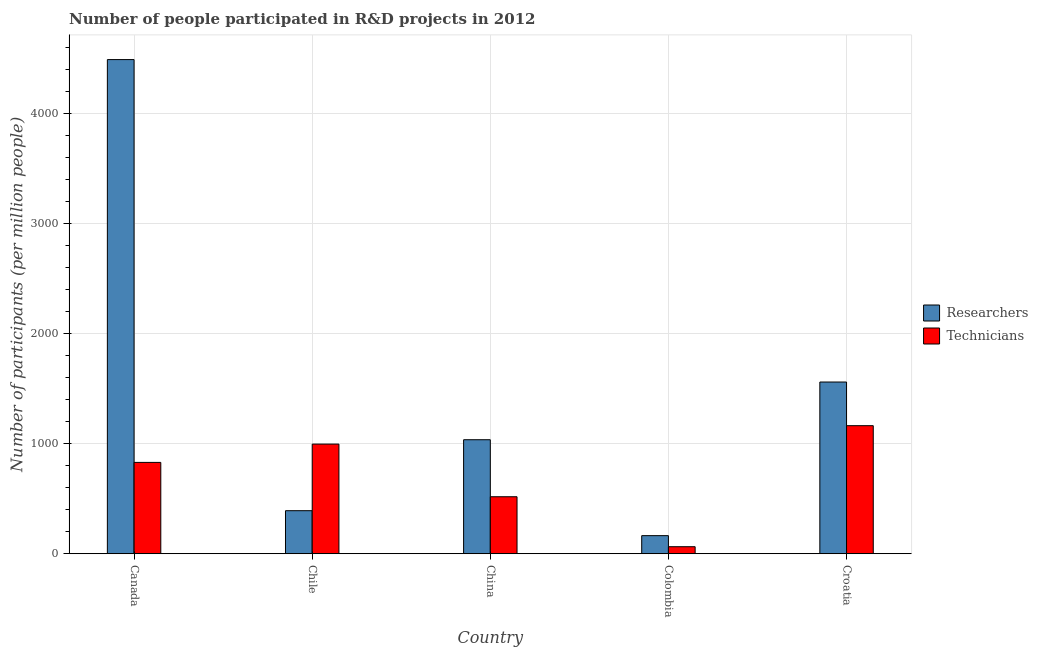How many different coloured bars are there?
Your answer should be compact. 2. How many groups of bars are there?
Provide a short and direct response. 5. Are the number of bars on each tick of the X-axis equal?
Keep it short and to the point. Yes. How many bars are there on the 2nd tick from the right?
Offer a very short reply. 2. What is the label of the 5th group of bars from the left?
Your answer should be compact. Croatia. In how many cases, is the number of bars for a given country not equal to the number of legend labels?
Your answer should be very brief. 0. What is the number of researchers in Croatia?
Ensure brevity in your answer.  1560.06. Across all countries, what is the maximum number of technicians?
Provide a succinct answer. 1163.4. Across all countries, what is the minimum number of technicians?
Your response must be concise. 63.85. In which country was the number of technicians maximum?
Your response must be concise. Croatia. In which country was the number of technicians minimum?
Make the answer very short. Colombia. What is the total number of technicians in the graph?
Make the answer very short. 3571.1. What is the difference between the number of researchers in Chile and that in Colombia?
Your response must be concise. 226.66. What is the difference between the number of technicians in Canada and the number of researchers in Colombia?
Ensure brevity in your answer.  665.6. What is the average number of researchers per country?
Your answer should be compact. 1528.19. What is the difference between the number of technicians and number of researchers in Croatia?
Provide a short and direct response. -396.66. In how many countries, is the number of researchers greater than 1200 ?
Your answer should be compact. 2. What is the ratio of the number of technicians in Chile to that in Colombia?
Provide a succinct answer. 15.6. What is the difference between the highest and the second highest number of technicians?
Keep it short and to the point. 167.19. What is the difference between the highest and the lowest number of technicians?
Ensure brevity in your answer.  1099.55. In how many countries, is the number of researchers greater than the average number of researchers taken over all countries?
Ensure brevity in your answer.  2. Is the sum of the number of researchers in Colombia and Croatia greater than the maximum number of technicians across all countries?
Make the answer very short. Yes. What does the 2nd bar from the left in China represents?
Ensure brevity in your answer.  Technicians. What does the 1st bar from the right in Canada represents?
Offer a terse response. Technicians. How many bars are there?
Your response must be concise. 10. Are all the bars in the graph horizontal?
Provide a succinct answer. No. How many countries are there in the graph?
Your answer should be very brief. 5. Does the graph contain grids?
Provide a succinct answer. Yes. What is the title of the graph?
Give a very brief answer. Number of people participated in R&D projects in 2012. Does "Register a property" appear as one of the legend labels in the graph?
Keep it short and to the point. No. What is the label or title of the Y-axis?
Give a very brief answer. Number of participants (per million people). What is the Number of participants (per million people) in Researchers in Canada?
Your response must be concise. 4489.77. What is the Number of participants (per million people) of Technicians in Canada?
Offer a very short reply. 829.89. What is the Number of participants (per million people) of Researchers in Chile?
Your answer should be compact. 390.95. What is the Number of participants (per million people) of Technicians in Chile?
Your answer should be very brief. 996.21. What is the Number of participants (per million people) in Researchers in China?
Provide a succinct answer. 1035.88. What is the Number of participants (per million people) of Technicians in China?
Your answer should be compact. 517.76. What is the Number of participants (per million people) of Researchers in Colombia?
Make the answer very short. 164.29. What is the Number of participants (per million people) in Technicians in Colombia?
Offer a terse response. 63.85. What is the Number of participants (per million people) of Researchers in Croatia?
Your answer should be compact. 1560.06. What is the Number of participants (per million people) in Technicians in Croatia?
Your answer should be compact. 1163.4. Across all countries, what is the maximum Number of participants (per million people) in Researchers?
Keep it short and to the point. 4489.77. Across all countries, what is the maximum Number of participants (per million people) in Technicians?
Ensure brevity in your answer.  1163.4. Across all countries, what is the minimum Number of participants (per million people) of Researchers?
Your answer should be compact. 164.29. Across all countries, what is the minimum Number of participants (per million people) of Technicians?
Give a very brief answer. 63.85. What is the total Number of participants (per million people) in Researchers in the graph?
Ensure brevity in your answer.  7640.95. What is the total Number of participants (per million people) of Technicians in the graph?
Offer a terse response. 3571.1. What is the difference between the Number of participants (per million people) in Researchers in Canada and that in Chile?
Your answer should be compact. 4098.82. What is the difference between the Number of participants (per million people) in Technicians in Canada and that in Chile?
Make the answer very short. -166.32. What is the difference between the Number of participants (per million people) in Researchers in Canada and that in China?
Your answer should be compact. 3453.89. What is the difference between the Number of participants (per million people) in Technicians in Canada and that in China?
Offer a terse response. 312.13. What is the difference between the Number of participants (per million people) in Researchers in Canada and that in Colombia?
Your answer should be very brief. 4325.48. What is the difference between the Number of participants (per million people) of Technicians in Canada and that in Colombia?
Your answer should be very brief. 766.04. What is the difference between the Number of participants (per million people) in Researchers in Canada and that in Croatia?
Keep it short and to the point. 2929.71. What is the difference between the Number of participants (per million people) in Technicians in Canada and that in Croatia?
Offer a very short reply. -333.51. What is the difference between the Number of participants (per million people) in Researchers in Chile and that in China?
Provide a succinct answer. -644.93. What is the difference between the Number of participants (per million people) of Technicians in Chile and that in China?
Make the answer very short. 478.45. What is the difference between the Number of participants (per million people) in Researchers in Chile and that in Colombia?
Make the answer very short. 226.66. What is the difference between the Number of participants (per million people) in Technicians in Chile and that in Colombia?
Your response must be concise. 932.36. What is the difference between the Number of participants (per million people) in Researchers in Chile and that in Croatia?
Make the answer very short. -1169.11. What is the difference between the Number of participants (per million people) in Technicians in Chile and that in Croatia?
Provide a short and direct response. -167.19. What is the difference between the Number of participants (per million people) of Researchers in China and that in Colombia?
Your answer should be compact. 871.59. What is the difference between the Number of participants (per million people) of Technicians in China and that in Colombia?
Give a very brief answer. 453.91. What is the difference between the Number of participants (per million people) of Researchers in China and that in Croatia?
Make the answer very short. -524.18. What is the difference between the Number of participants (per million people) in Technicians in China and that in Croatia?
Offer a terse response. -645.64. What is the difference between the Number of participants (per million people) of Researchers in Colombia and that in Croatia?
Offer a very short reply. -1395.77. What is the difference between the Number of participants (per million people) in Technicians in Colombia and that in Croatia?
Ensure brevity in your answer.  -1099.55. What is the difference between the Number of participants (per million people) in Researchers in Canada and the Number of participants (per million people) in Technicians in Chile?
Provide a short and direct response. 3493.56. What is the difference between the Number of participants (per million people) in Researchers in Canada and the Number of participants (per million people) in Technicians in China?
Make the answer very short. 3972.01. What is the difference between the Number of participants (per million people) of Researchers in Canada and the Number of participants (per million people) of Technicians in Colombia?
Provide a succinct answer. 4425.92. What is the difference between the Number of participants (per million people) in Researchers in Canada and the Number of participants (per million people) in Technicians in Croatia?
Your answer should be very brief. 3326.37. What is the difference between the Number of participants (per million people) of Researchers in Chile and the Number of participants (per million people) of Technicians in China?
Your response must be concise. -126.81. What is the difference between the Number of participants (per million people) of Researchers in Chile and the Number of participants (per million people) of Technicians in Colombia?
Offer a terse response. 327.1. What is the difference between the Number of participants (per million people) of Researchers in Chile and the Number of participants (per million people) of Technicians in Croatia?
Provide a short and direct response. -772.45. What is the difference between the Number of participants (per million people) in Researchers in China and the Number of participants (per million people) in Technicians in Colombia?
Keep it short and to the point. 972.03. What is the difference between the Number of participants (per million people) in Researchers in China and the Number of participants (per million people) in Technicians in Croatia?
Offer a very short reply. -127.52. What is the difference between the Number of participants (per million people) in Researchers in Colombia and the Number of participants (per million people) in Technicians in Croatia?
Provide a succinct answer. -999.11. What is the average Number of participants (per million people) in Researchers per country?
Your response must be concise. 1528.19. What is the average Number of participants (per million people) of Technicians per country?
Ensure brevity in your answer.  714.22. What is the difference between the Number of participants (per million people) in Researchers and Number of participants (per million people) in Technicians in Canada?
Ensure brevity in your answer.  3659.88. What is the difference between the Number of participants (per million people) of Researchers and Number of participants (per million people) of Technicians in Chile?
Your answer should be very brief. -605.26. What is the difference between the Number of participants (per million people) of Researchers and Number of participants (per million people) of Technicians in China?
Keep it short and to the point. 518.12. What is the difference between the Number of participants (per million people) in Researchers and Number of participants (per million people) in Technicians in Colombia?
Your response must be concise. 100.44. What is the difference between the Number of participants (per million people) of Researchers and Number of participants (per million people) of Technicians in Croatia?
Your answer should be compact. 396.66. What is the ratio of the Number of participants (per million people) in Researchers in Canada to that in Chile?
Give a very brief answer. 11.48. What is the ratio of the Number of participants (per million people) of Technicians in Canada to that in Chile?
Your response must be concise. 0.83. What is the ratio of the Number of participants (per million people) of Researchers in Canada to that in China?
Keep it short and to the point. 4.33. What is the ratio of the Number of participants (per million people) of Technicians in Canada to that in China?
Give a very brief answer. 1.6. What is the ratio of the Number of participants (per million people) of Researchers in Canada to that in Colombia?
Ensure brevity in your answer.  27.33. What is the ratio of the Number of participants (per million people) of Technicians in Canada to that in Colombia?
Keep it short and to the point. 13. What is the ratio of the Number of participants (per million people) in Researchers in Canada to that in Croatia?
Keep it short and to the point. 2.88. What is the ratio of the Number of participants (per million people) of Technicians in Canada to that in Croatia?
Your answer should be compact. 0.71. What is the ratio of the Number of participants (per million people) of Researchers in Chile to that in China?
Offer a very short reply. 0.38. What is the ratio of the Number of participants (per million people) in Technicians in Chile to that in China?
Provide a succinct answer. 1.92. What is the ratio of the Number of participants (per million people) in Researchers in Chile to that in Colombia?
Your answer should be very brief. 2.38. What is the ratio of the Number of participants (per million people) of Technicians in Chile to that in Colombia?
Keep it short and to the point. 15.6. What is the ratio of the Number of participants (per million people) of Researchers in Chile to that in Croatia?
Your answer should be compact. 0.25. What is the ratio of the Number of participants (per million people) of Technicians in Chile to that in Croatia?
Provide a succinct answer. 0.86. What is the ratio of the Number of participants (per million people) of Researchers in China to that in Colombia?
Offer a very short reply. 6.31. What is the ratio of the Number of participants (per million people) in Technicians in China to that in Colombia?
Your answer should be very brief. 8.11. What is the ratio of the Number of participants (per million people) in Researchers in China to that in Croatia?
Provide a short and direct response. 0.66. What is the ratio of the Number of participants (per million people) in Technicians in China to that in Croatia?
Offer a terse response. 0.45. What is the ratio of the Number of participants (per million people) in Researchers in Colombia to that in Croatia?
Your response must be concise. 0.11. What is the ratio of the Number of participants (per million people) of Technicians in Colombia to that in Croatia?
Give a very brief answer. 0.05. What is the difference between the highest and the second highest Number of participants (per million people) in Researchers?
Make the answer very short. 2929.71. What is the difference between the highest and the second highest Number of participants (per million people) of Technicians?
Ensure brevity in your answer.  167.19. What is the difference between the highest and the lowest Number of participants (per million people) of Researchers?
Make the answer very short. 4325.48. What is the difference between the highest and the lowest Number of participants (per million people) of Technicians?
Make the answer very short. 1099.55. 